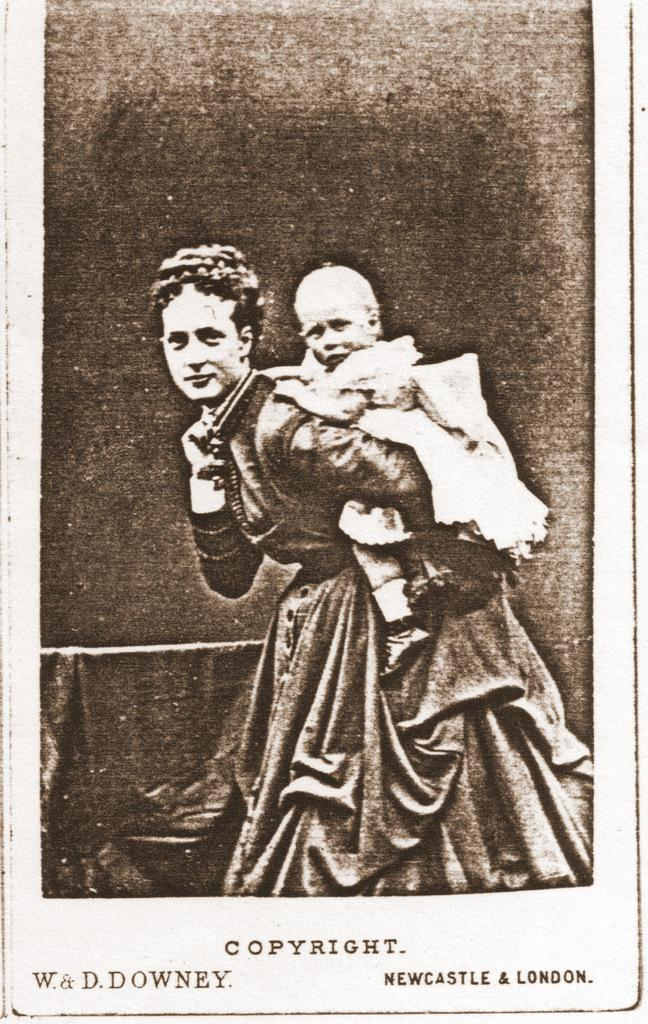What is present in the image that contains information? There is a paper in the image that contains text. What is depicted on the paper? The paper contains an image of a woman caring for a baby. What type of branch can be seen growing through the window in the image? There is no branch or window present in the image; it only contains a paper with text and an image of a woman caring for a baby. 